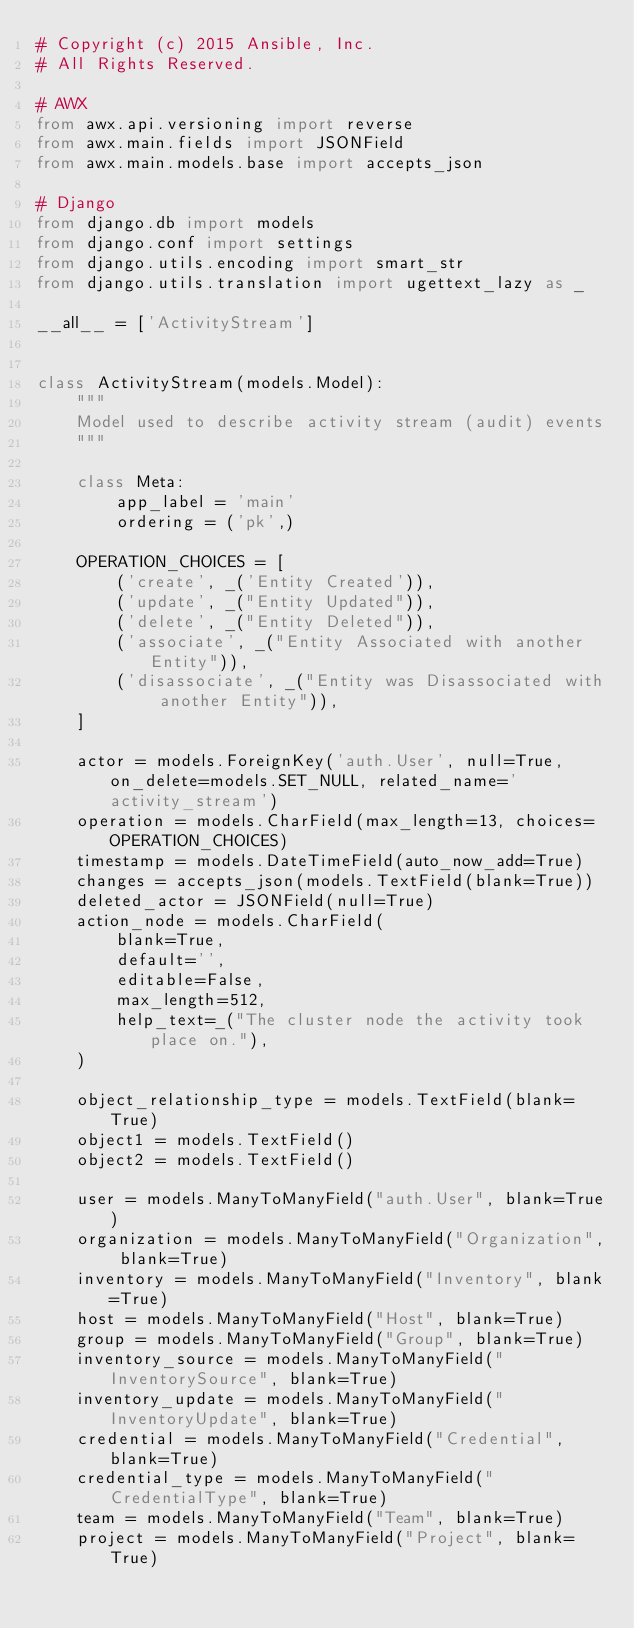Convert code to text. <code><loc_0><loc_0><loc_500><loc_500><_Python_># Copyright (c) 2015 Ansible, Inc.
# All Rights Reserved.

# AWX
from awx.api.versioning import reverse
from awx.main.fields import JSONField
from awx.main.models.base import accepts_json

# Django
from django.db import models
from django.conf import settings
from django.utils.encoding import smart_str
from django.utils.translation import ugettext_lazy as _

__all__ = ['ActivityStream']


class ActivityStream(models.Model):
    """
    Model used to describe activity stream (audit) events
    """

    class Meta:
        app_label = 'main'
        ordering = ('pk',)

    OPERATION_CHOICES = [
        ('create', _('Entity Created')),
        ('update', _("Entity Updated")),
        ('delete', _("Entity Deleted")),
        ('associate', _("Entity Associated with another Entity")),
        ('disassociate', _("Entity was Disassociated with another Entity")),
    ]

    actor = models.ForeignKey('auth.User', null=True, on_delete=models.SET_NULL, related_name='activity_stream')
    operation = models.CharField(max_length=13, choices=OPERATION_CHOICES)
    timestamp = models.DateTimeField(auto_now_add=True)
    changes = accepts_json(models.TextField(blank=True))
    deleted_actor = JSONField(null=True)
    action_node = models.CharField(
        blank=True,
        default='',
        editable=False,
        max_length=512,
        help_text=_("The cluster node the activity took place on."),
    )

    object_relationship_type = models.TextField(blank=True)
    object1 = models.TextField()
    object2 = models.TextField()

    user = models.ManyToManyField("auth.User", blank=True)
    organization = models.ManyToManyField("Organization", blank=True)
    inventory = models.ManyToManyField("Inventory", blank=True)
    host = models.ManyToManyField("Host", blank=True)
    group = models.ManyToManyField("Group", blank=True)
    inventory_source = models.ManyToManyField("InventorySource", blank=True)
    inventory_update = models.ManyToManyField("InventoryUpdate", blank=True)
    credential = models.ManyToManyField("Credential", blank=True)
    credential_type = models.ManyToManyField("CredentialType", blank=True)
    team = models.ManyToManyField("Team", blank=True)
    project = models.ManyToManyField("Project", blank=True)</code> 